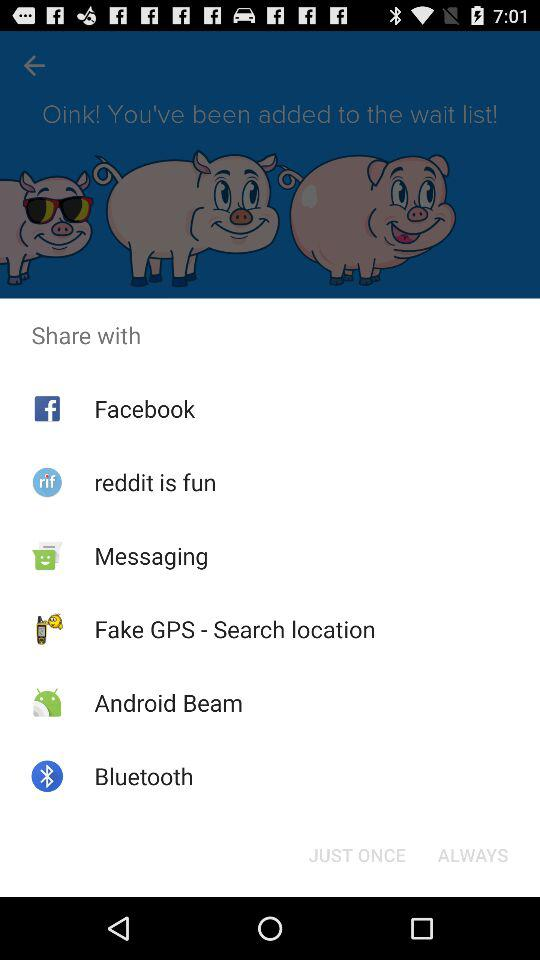Which are the different sharing options? The different sharing options are "Facebook", "reddit is fun", "Messaging", "Fake GPS - Search location", "Android Beam" and "Bluetooth". 